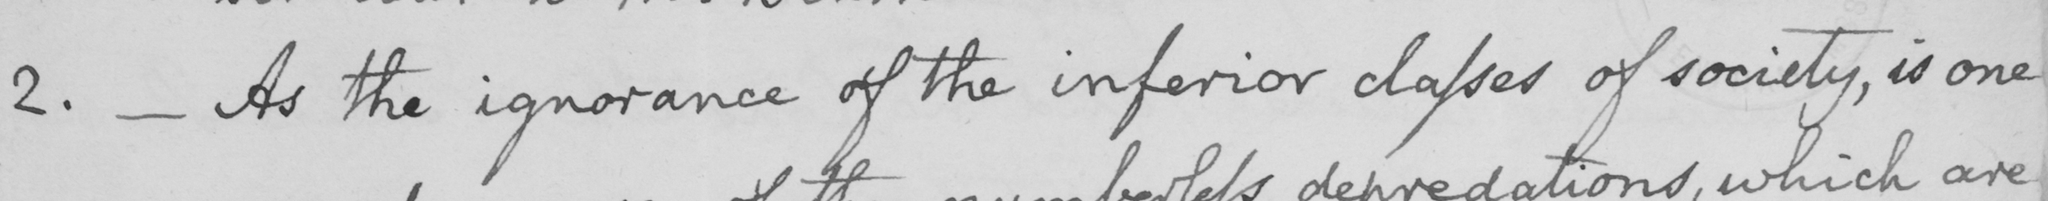What does this handwritten line say? 2 .  _  As the ignorance of the inferior classes of society , is one 